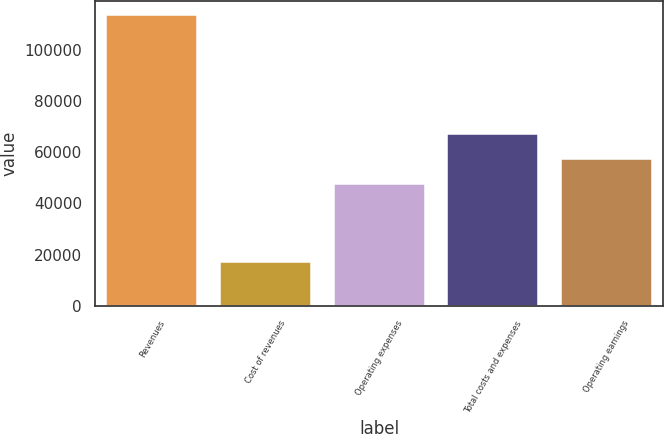Convert chart to OTSL. <chart><loc_0><loc_0><loc_500><loc_500><bar_chart><fcel>Revenues<fcel>Cost of revenues<fcel>Operating expenses<fcel>Total costs and expenses<fcel>Operating earnings<nl><fcel>113314<fcel>16981<fcel>47691<fcel>66957.6<fcel>57324.3<nl></chart> 